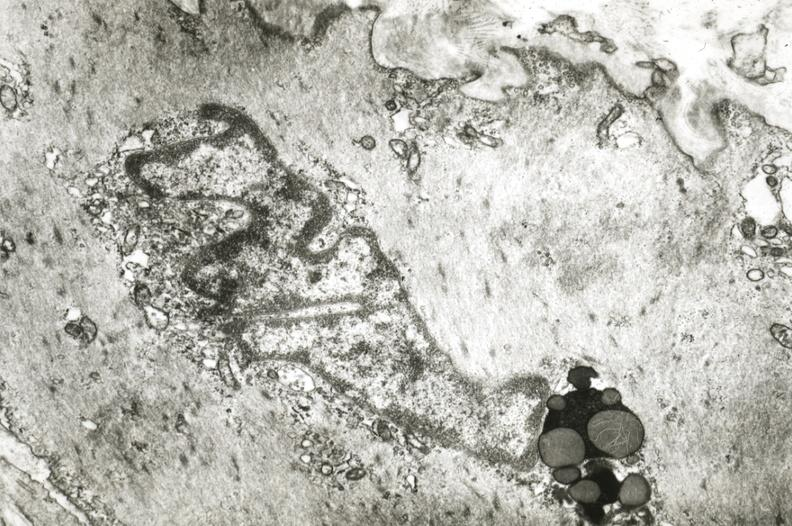s vasculature present?
Answer the question using a single word or phrase. Yes 